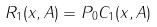Convert formula to latex. <formula><loc_0><loc_0><loc_500><loc_500>R _ { 1 } ( x , A ) = P _ { 0 } C _ { 1 } ( x , A )</formula> 